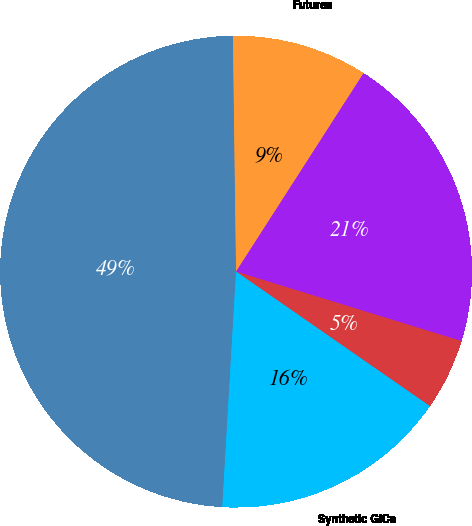Convert chart. <chart><loc_0><loc_0><loc_500><loc_500><pie_chart><fcel>Swaps<fcel>Futures<fcel>Options<fcel>Forwards<fcel>Synthetic GICs<nl><fcel>48.86%<fcel>9.3%<fcel>20.67%<fcel>4.9%<fcel>16.27%<nl></chart> 